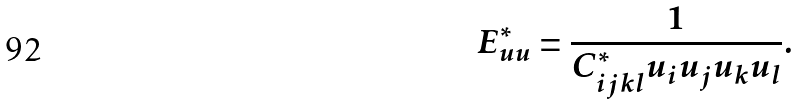<formula> <loc_0><loc_0><loc_500><loc_500>E ^ { * } _ { u u } = \frac { 1 } { C _ { i j k l } ^ { * } u _ { i } u _ { j } u _ { k } u _ { l } } .</formula> 